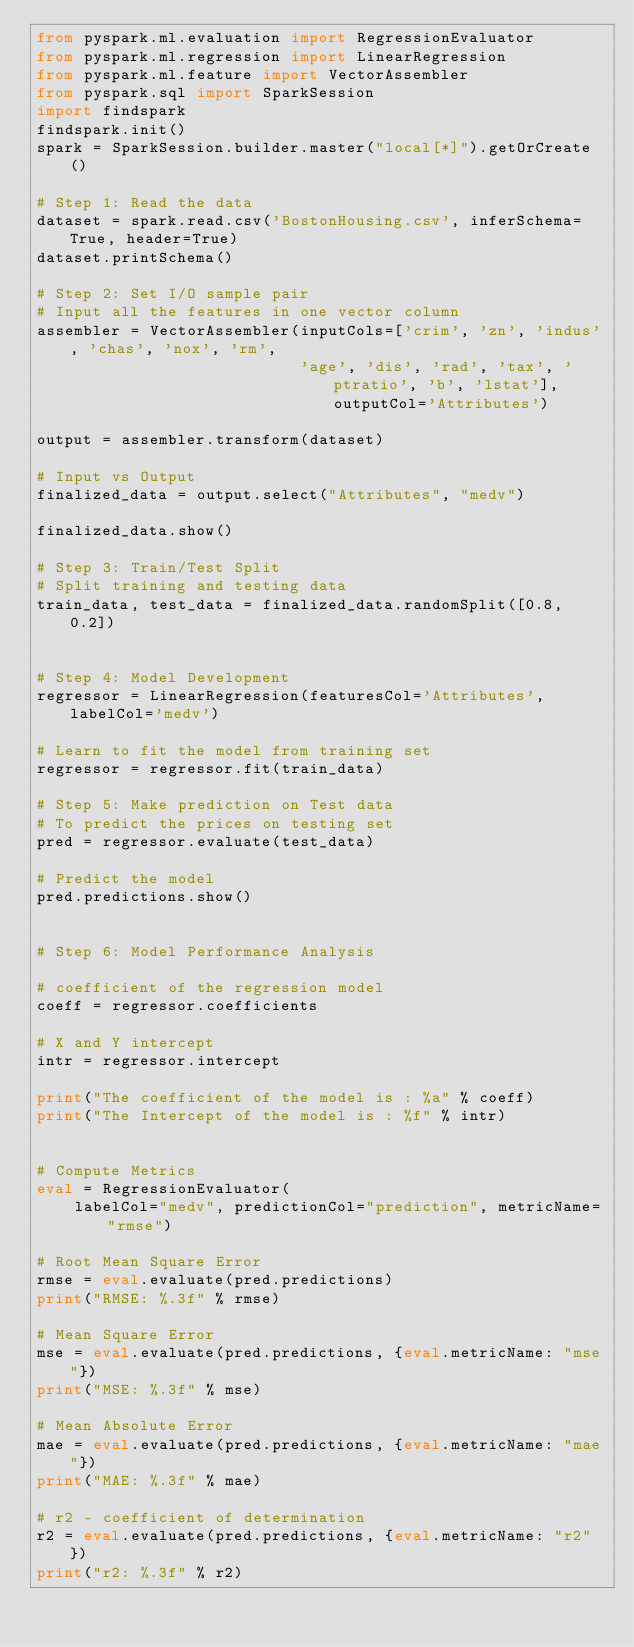<code> <loc_0><loc_0><loc_500><loc_500><_Python_>from pyspark.ml.evaluation import RegressionEvaluator
from pyspark.ml.regression import LinearRegression
from pyspark.ml.feature import VectorAssembler
from pyspark.sql import SparkSession
import findspark
findspark.init()
spark = SparkSession.builder.master("local[*]").getOrCreate()

# Step 1: Read the data
dataset = spark.read.csv('BostonHousing.csv', inferSchema=True, header=True)
dataset.printSchema()

# Step 2: Set I/O sample pair
# Input all the features in one vector column
assembler = VectorAssembler(inputCols=['crim', 'zn', 'indus', 'chas', 'nox', 'rm',
                            'age', 'dis', 'rad', 'tax', 'ptratio', 'b', 'lstat'], outputCol='Attributes')

output = assembler.transform(dataset)

# Input vs Output
finalized_data = output.select("Attributes", "medv")

finalized_data.show()

# Step 3: Train/Test Split
# Split training and testing data
train_data, test_data = finalized_data.randomSplit([0.8, 0.2])


# Step 4: Model Development
regressor = LinearRegression(featuresCol='Attributes', labelCol='medv')

# Learn to fit the model from training set
regressor = regressor.fit(train_data)

# Step 5: Make prediction on Test data
# To predict the prices on testing set
pred = regressor.evaluate(test_data)

# Predict the model
pred.predictions.show()


# Step 6: Model Performance Analysis

# coefficient of the regression model
coeff = regressor.coefficients

# X and Y intercept
intr = regressor.intercept

print("The coefficient of the model is : %a" % coeff)
print("The Intercept of the model is : %f" % intr)


# Compute Metrics
eval = RegressionEvaluator(
    labelCol="medv", predictionCol="prediction", metricName="rmse")

# Root Mean Square Error
rmse = eval.evaluate(pred.predictions)
print("RMSE: %.3f" % rmse)

# Mean Square Error
mse = eval.evaluate(pred.predictions, {eval.metricName: "mse"})
print("MSE: %.3f" % mse)

# Mean Absolute Error
mae = eval.evaluate(pred.predictions, {eval.metricName: "mae"})
print("MAE: %.3f" % mae)

# r2 - coefficient of determination
r2 = eval.evaluate(pred.predictions, {eval.metricName: "r2"})
print("r2: %.3f" % r2)
</code> 